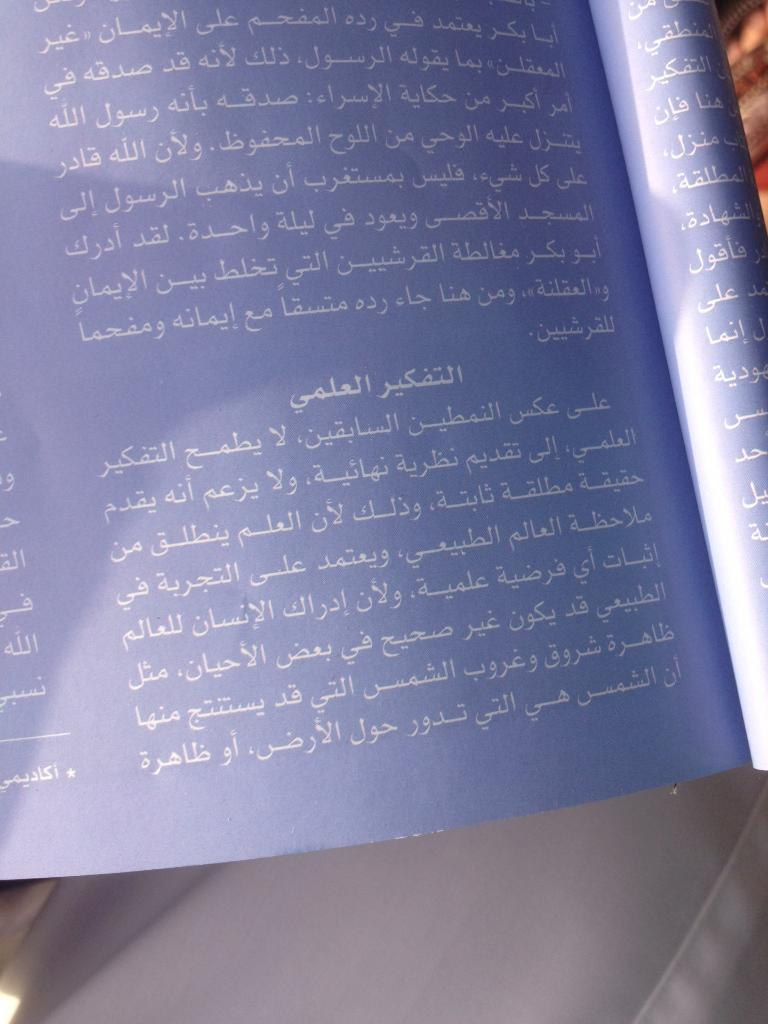What is the main subject of the image? There is a book with text in the image. Can you describe the book in the image? The book has text, which suggests it is a reading material. What can be seen in the background of the image? There are objects visible in the background of the image, but their specific details are not mentioned in the provided facts. How does the sister kick the jelly in the image? There is no sister or jelly present in the image; it only features a book with text. 